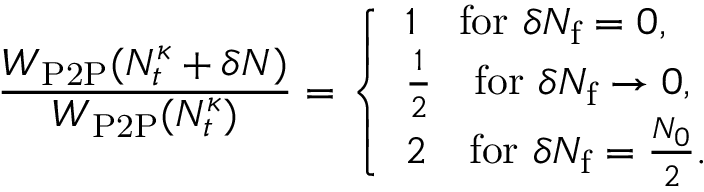<formula> <loc_0><loc_0><loc_500><loc_500>\frac { W _ { P 2 P } ( N _ { t } ^ { \kappa } + \delta N ) } { W _ { P 2 P } ( N _ { t } ^ { \kappa } ) } = \left \{ \begin{array} { l l } { 1 \quad f o r \delta N _ { f } = 0 , } \\ { \frac { 1 } { 2 } \quad f o r \delta N _ { f } \to 0 , } \\ { 2 \quad f o r \delta N _ { f } = \frac { N _ { 0 } } { 2 } . } \end{array}</formula> 